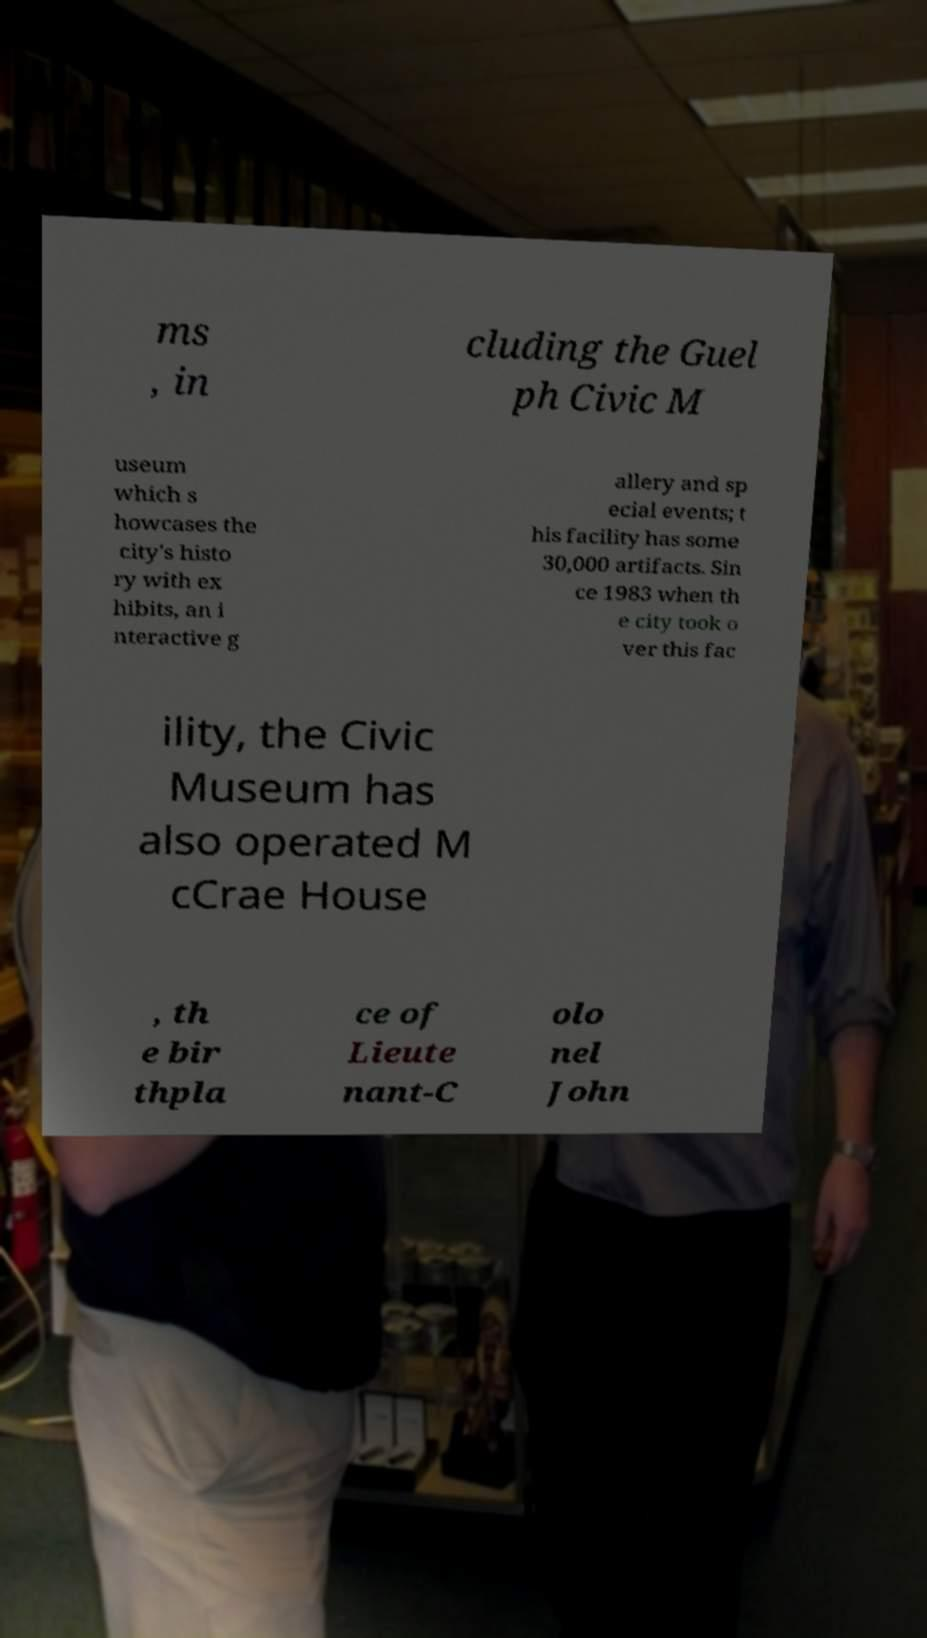There's text embedded in this image that I need extracted. Can you transcribe it verbatim? ms , in cluding the Guel ph Civic M useum which s howcases the city's histo ry with ex hibits, an i nteractive g allery and sp ecial events; t his facility has some 30,000 artifacts. Sin ce 1983 when th e city took o ver this fac ility, the Civic Museum has also operated M cCrae House , th e bir thpla ce of Lieute nant-C olo nel John 